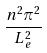<formula> <loc_0><loc_0><loc_500><loc_500>\frac { n ^ { 2 } \pi ^ { 2 } } { L _ { e } ^ { 2 } }</formula> 